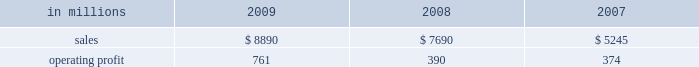Distribution xpedx , our north american merchant distribution business , distributes products and services to a number of customer markets including : commercial printers with printing papers and graphic pre-press , printing presses and post-press equipment ; building services and away-from-home markets with facility supplies ; manufacturers with packaging supplies and equipment ; and to a growing number of customers , we exclusively provide distribution capabilities including warehousing and delivery services .
Xpedx is the leading wholesale distribution marketer in these customer and product segments in north america , operating 122 warehouse locations and 130 retail stores in the united states , mexico and cana- forest products international paper owns and manages approx- imately 200000 acres of forestlands and develop- ment properties in the united states , mostly in the south .
Our remaining forestlands are managed as a portfolio to optimize the economic value to our shareholders .
Most of our portfolio represents prop- erties that are likely to be sold to investors and other buyers for various purposes .
Specialty businesses and other chemicals : this business was sold in the first quarter of 2007 .
Ilim holding s.a .
In october 2007 , international paper and ilim holding s.a .
( ilim ) completed a 50:50 joint venture to operate a pulp and paper business located in russia .
Ilim 2019s facilities include three paper mills located in bratsk , ust-ilimsk , and koryazhma , russia , with combined total pulp and paper capacity of over 2.5 million tons .
Ilim has exclusive harvesting rights on timberland and forest areas exceeding 12.8 million acres ( 5.2 million hectares ) .
Products and brand designations appearing in italics are trademarks of international paper or a related company .
Industry segment results industrial packaging demand for industrial packaging products is closely correlated with non-durable industrial goods pro- duction , as well as with demand for processed foods , poultry , meat and agricultural products .
In addition to prices and volumes , major factors affecting the profitability of industrial packaging are raw material and energy costs , freight costs , manufacturing effi- ciency and product mix .
Industrial packaging results for 2009 and 2008 include the cbpr business acquired in the 2008 third quarter .
Net sales for 2009 increased 16% ( 16 % ) to $ 8.9 billion compared with $ 7.7 billion in 2008 , and 69% ( 69 % ) compared with $ 5.2 billion in 2007 .
Operating profits were 95% ( 95 % ) higher in 2009 than in 2008 and more than double 2007 levels .
Benefits from higher total year-over-year shipments , including the impact of the cbpr business , ( $ 11 million ) , favorable operating costs ( $ 294 million ) , and lower raw material and freight costs ( $ 295 million ) were parti- ally offset by the effects of lower price realizations ( $ 243 million ) , higher corporate overhead allocations ( $ 85 million ) , incremental integration costs asso- ciated with the acquisition of the cbpr business ( $ 3 million ) and higher other costs ( $ 7 million ) .
Additionally , operating profits in 2009 included a gain of $ 849 million relating to alternative fuel mix- ture credits , u.s .
Plant closure costs of $ 653 million , and costs associated with the shutdown of the eti- enne mill in france of $ 87 million .
Industrial packaging in millions 2009 2008 2007 .
North american industrial packaging results include the net sales and operating profits of the cbpr business from the august 4 , 2008 acquis- ition date .
Net sales were $ 7.6 billion in 2009 com- pared with $ 6.2 billion in 2008 and $ 3.9 billion in 2007 .
Operating profits in 2009 were $ 791 million ( $ 682 million excluding alternative fuel mixture cred- its , mill closure costs and costs associated with the cbpr integration ) compared with $ 322 million ( $ 414 million excluding charges related to the write-up of cbpr inventory to fair value , cbpr integration costs and other facility closure costs ) in 2008 and $ 305 million in 2007 .
Excluding the effect of the cbpr acquisition , con- tainerboard and box shipments were lower in 2009 compared with 2008 reflecting weaker customer demand .
Average sales price realizations were sig- nificantly lower for both containerboard and boxes due to weaker world-wide economic conditions .
However , average sales margins for boxes .
What is the value of operating expenses and other costs concerning the activities , in 2009? 
Rationale: it is the value of sales ( operating income ) subtracted by the value of operating profit .
Computations: (8890 - 761)
Answer: 8129.0. 